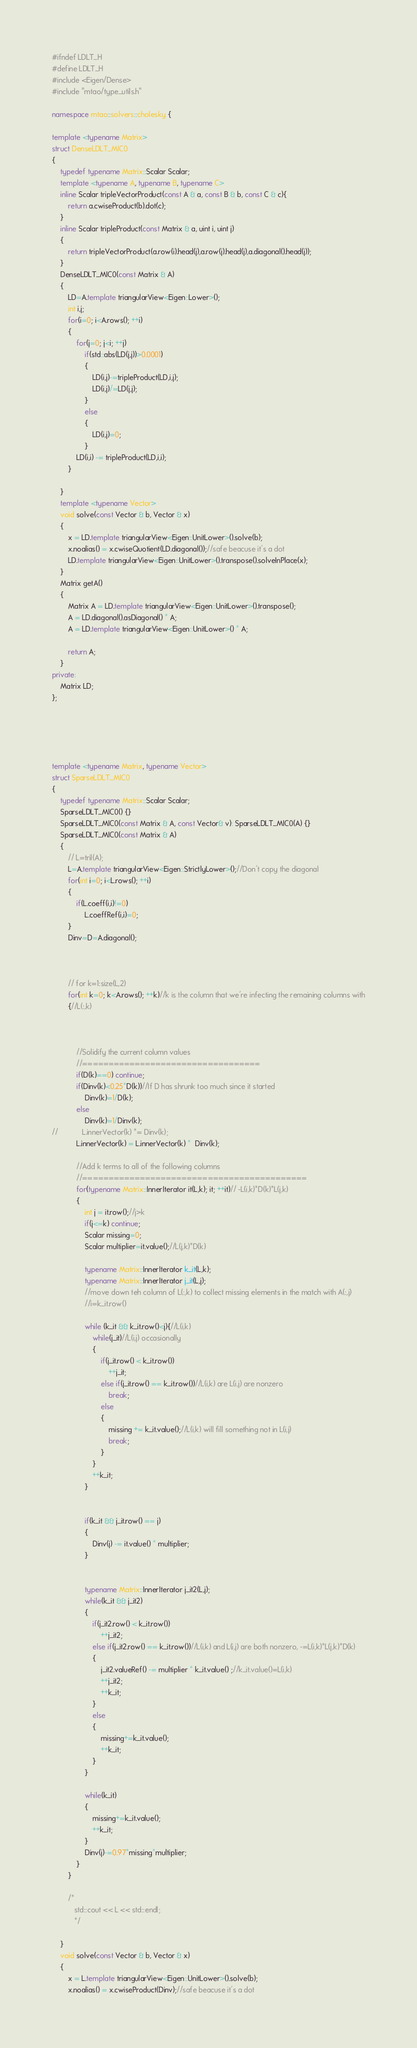<code> <loc_0><loc_0><loc_500><loc_500><_C++_>#ifndef LDLT_H
#define LDLT_H
#include <Eigen/Dense>
#include "mtao/type_utils.h"

namespace mtao::solvers::cholesky {

template <typename Matrix>
struct DenseLDLT_MIC0
{
    typedef typename Matrix::Scalar Scalar;
    template <typename A, typename B, typename C>
    inline Scalar tripleVectorProduct(const A & a, const B & b, const C & c){
        return a.cwiseProduct(b).dot(c);
    }
    inline Scalar tripleProduct(const Matrix & a, uint i, uint j)
    {
        return tripleVectorProduct(a.row(i).head(j),a.row(j).head(j),a.diagonal().head(j));
    }
    DenseLDLT_MIC0(const Matrix & A)
    {
        LD=A.template triangularView<Eigen::Lower>();
        int i,j;
        for(i=0; i<A.rows(); ++i)
        {
            for(j=0; j<i; ++j)
                if(std::abs(LD(j,j))>0.0001)
                {
                    LD(i,j)-=tripleProduct(LD,i,j);
                    LD(i,j)/=LD(j,j);
                }
                else
                {
                    LD(i,j)=0;
                }
            LD(i,i) -= tripleProduct(LD,i,i);
        }

    }
    template <typename Vector>
    void solve(const Vector & b, Vector & x)
    {
        x = LD.template triangularView<Eigen::UnitLower>().solve(b);
        x.noalias() = x.cwiseQuotient(LD.diagonal());//safe beacuse it's a dot
        LD.template triangularView<Eigen::UnitLower>().transpose().solveInPlace(x);
    }
    Matrix getA()
    {
        Matrix A = LD.template triangularView<Eigen::UnitLower>().transpose();
        A = LD.diagonal().asDiagonal() * A;
        A = LD.template triangularView<Eigen::UnitLower>() * A;

        return A;
    }
private:
    Matrix LD;
};





template <typename Matrix, typename Vector>
struct SparseLDLT_MIC0
{
    typedef typename Matrix::Scalar Scalar;
    SparseLDLT_MIC0() {}
    SparseLDLT_MIC0(const Matrix & A, const Vector& v): SparseLDLT_MIC0(A) {}
    SparseLDLT_MIC0(const Matrix & A)
    {
        // L=tril(A);
        L=A.template triangularView<Eigen::StrictlyLower>();//Don't copy the diagonal
        for(int i=0; i<L.rows(); ++i)
        {
            if(L.coeff(i,i)!=0)
                L.coeffRef(i,i)=0;
        }
        Dinv=D=A.diagonal();



        // for k=1:size(L,2)
        for(int k=0; k<A.rows(); ++k)//k is the column that we're infecting the remaining columns with
        {//L(:,k)



            //Solidify the current column values
            //==================================
            if(D(k)==0) continue;
            if(Dinv(k)<0.25*D(k))//If D has shrunk too much since it started
                Dinv(k)=1/D(k);
            else
                Dinv(k)=1/Dinv(k);
//            L.innerVector(k) *= Dinv(k);
            L.innerVector(k) = L.innerVector(k) *  Dinv(k);

            //Add k terms to all of the following columns
            //===========================================
            for(typename Matrix::InnerIterator it(L,k); it; ++it)// -L(i,k)*D(k)*L(j,k)
            {
                int j = it.row();//j>k
                if(j<=k) continue;
                Scalar missing=0;
                Scalar multiplier=it.value();//L(j,k)*D(k)

                typename Matrix::InnerIterator k_it(L,k);
                typename Matrix::InnerIterator j_it(L,j);
                //move down teh column of L(:,k) to collect missing elements in the match with A(:,j)
                //i=k_it.row()

                while (k_it && k_it.row()<j){//L(i,k)
                    while(j_it)//L(i,j) occasionally
                    {
                        if(j_it.row() < k_it.row())
                            ++j_it;
                        else if(j_it.row() == k_it.row())//L(i,k) are L(i,j) are nonzero
                            break;
                        else
                        {
                            missing += k_it.value();//L(i,k) will fill something not in L(i,j)
                            break;
                        }
                    }
                    ++k_it;
                }


                if(k_it && j_it.row() == j)
                {
                    Dinv(j) -= it.value() * multiplier;
                }


                typename Matrix::InnerIterator j_it2(L,j);
                while(k_it && j_it2)
                {
                    if(j_it2.row() < k_it.row())
                        ++j_it2;
                    else if(j_it2.row() == k_it.row())//L(i,k) and L(i,j) are both nonzero, -=L(i,k)*L(j,k)*D(k)
                    {
                        j_it2.valueRef() -= multiplier * k_it.value() ;//k_it.value()=L(i,k)
                        ++j_it2;
                        ++k_it;
                    }
                    else
                    {
                        missing+=k_it.value();
                        ++k_it;
                    }
                }

                while(k_it)
                {
                    missing+=k_it.value();
                    ++k_it;
                }
                Dinv(j)-=0.97*missing*multiplier;
            }
        }

        /*
           std::cout << L << std::endl;
           */

    }
    void solve(const Vector & b, Vector & x)
    {
        x = L.template triangularView<Eigen::UnitLower>().solve(b);
        x.noalias() = x.cwiseProduct(Dinv);//safe beacuse it's a dot</code> 